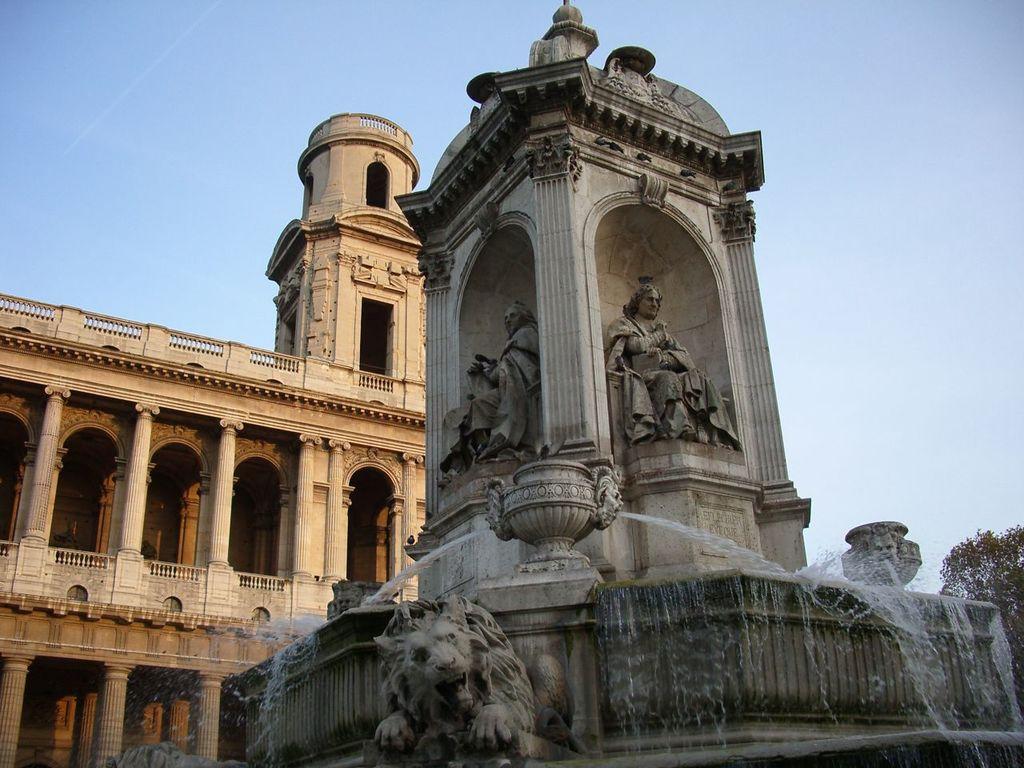Please provide a concise description of this image. In the image there are fountains with walls, sculptures and pillars. And also there are arches sculptures of persons. Behind them there is a building with walls, pillars, arches, railings and rooms. At the top of the image there is sky. In the bottom right corner of the image there are trees. 